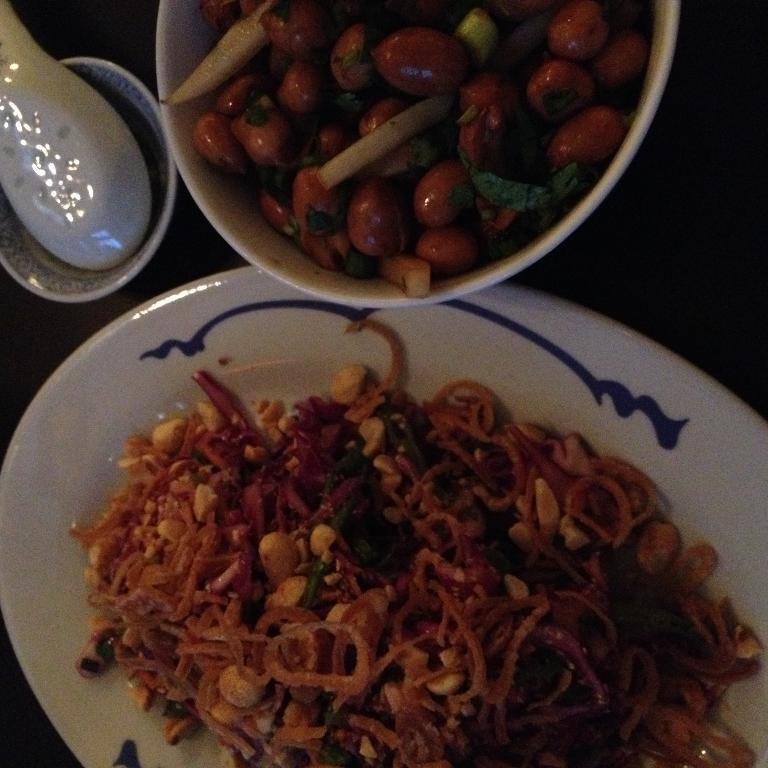Could you give a brief overview of what you see in this image? In this picture there is a plate at the bottom side of the image, which contains noodles and there is a bowl at the top side of the image, which contains food items in it, there is another bowl and a spoon on the left side of the image. 